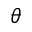<formula> <loc_0><loc_0><loc_500><loc_500>\theta</formula> 